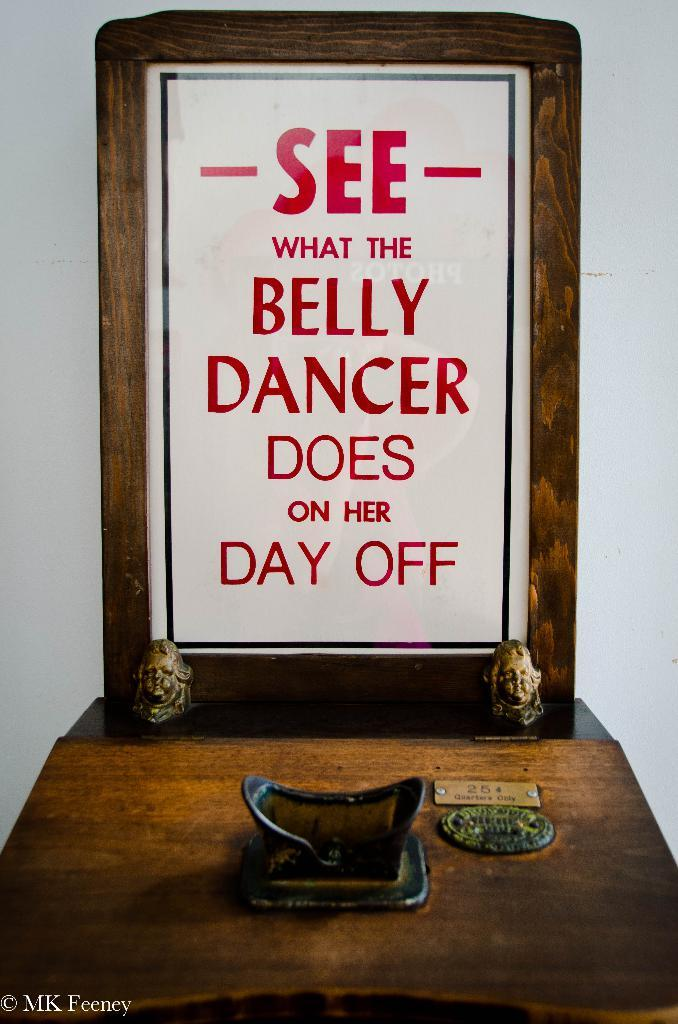What can be seen on the table in the image? There are objects on the table in the image. What is written on the board in the image? There is a board with a quotation in the image. What is visible in the background of the image? There is a wall in the background of the image. Can you describe any additional features of the image? There is a watermark on the image. What type of vegetable is growing on the wall in the image? There are no vegetables visible in the image, and the wall is not shown as a growing area for plants. What is the color of the sky in the image? The sky is not visible in the image, as it is not mentioned in the provided facts. 